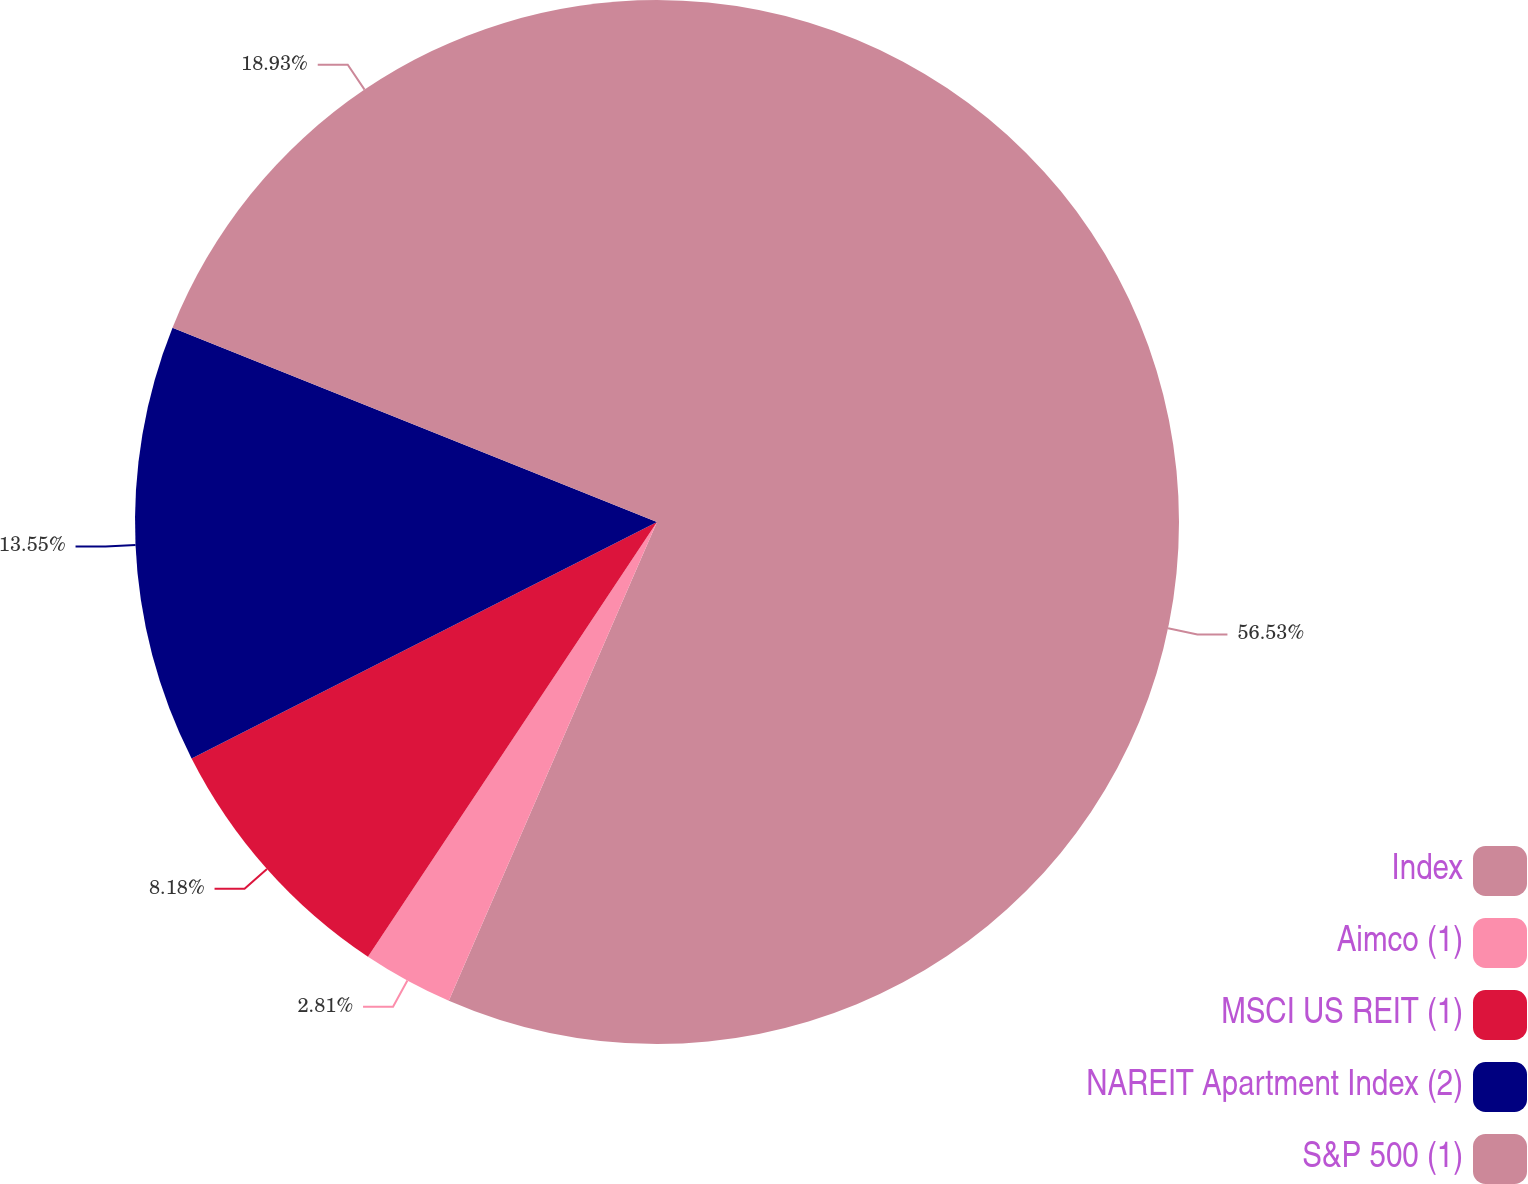Convert chart. <chart><loc_0><loc_0><loc_500><loc_500><pie_chart><fcel>Index<fcel>Aimco (1)<fcel>MSCI US REIT (1)<fcel>NAREIT Apartment Index (2)<fcel>S&P 500 (1)<nl><fcel>56.53%<fcel>2.81%<fcel>8.18%<fcel>13.55%<fcel>18.93%<nl></chart> 